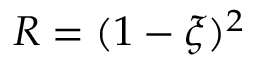<formula> <loc_0><loc_0><loc_500><loc_500>R = ( 1 - \xi ) ^ { 2 }</formula> 